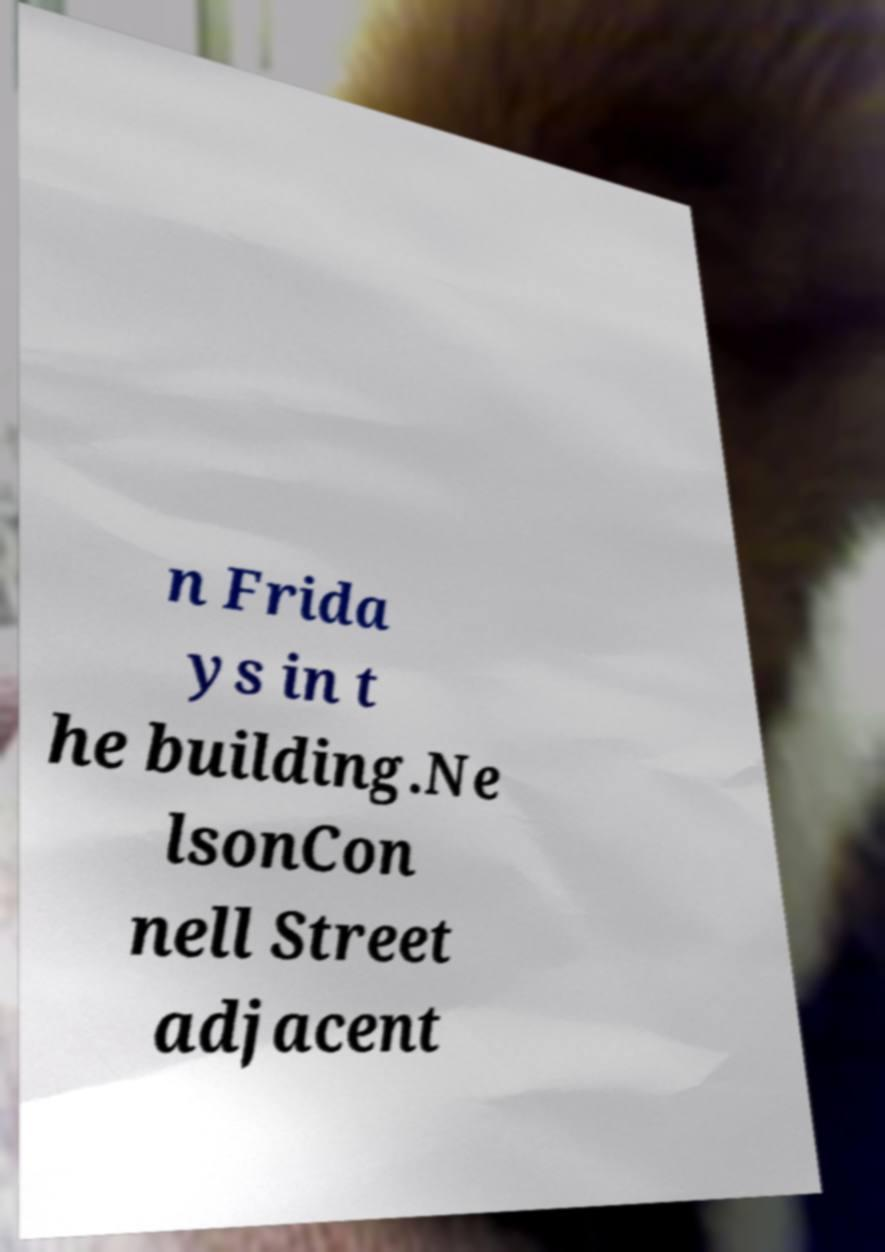Can you read and provide the text displayed in the image?This photo seems to have some interesting text. Can you extract and type it out for me? n Frida ys in t he building.Ne lsonCon nell Street adjacent 